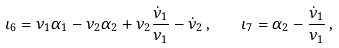<formula> <loc_0><loc_0><loc_500><loc_500>\iota _ { 6 } = \nu _ { 1 } \alpha _ { 1 } - \nu _ { 2 } \alpha _ { 2 } + \nu _ { 2 } \frac { \dot { \nu } _ { 1 } } { \nu _ { 1 } } - \dot { \nu } _ { 2 } \, , \quad \iota _ { 7 } = \alpha _ { 2 } - \frac { \dot { \nu } _ { 1 } } { \nu _ { 1 } } \, ,</formula> 